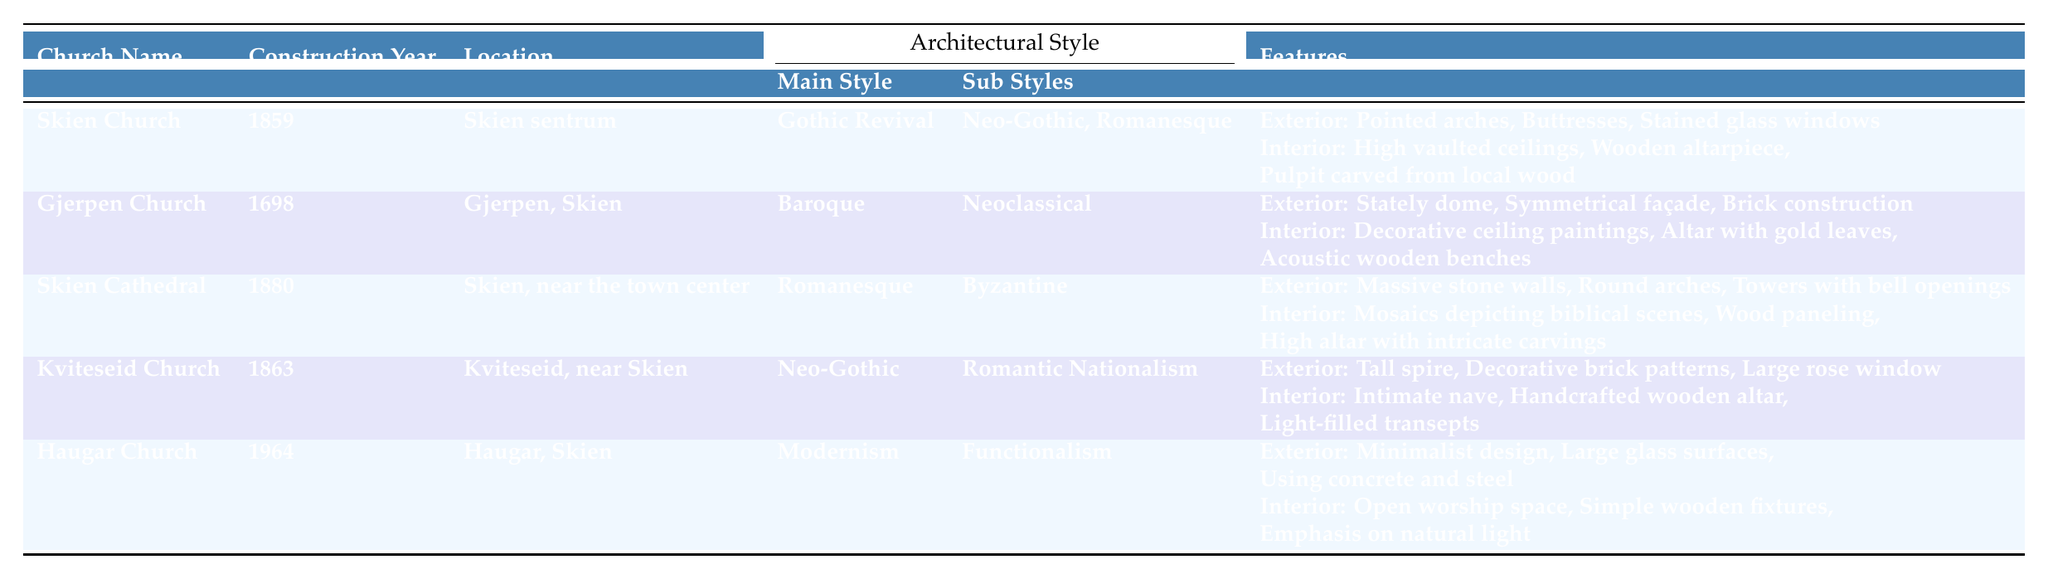What is the architectural style of Skien Church? The table shows that the main architectural style of Skien Church is Gothic Revival.
Answer: Gothic Revival Which church was constructed in 1964? According to the table, the church constructed in 1964 is Haugar Church.
Answer: Haugar Church What features are found in the interior of Gjerpen Church? The table lists the interior features of Gjerpen Church as decorative ceiling paintings, an altar with gold leaves, and acoustic wooden benches.
Answer: Decorative ceiling paintings, altar with gold leaves, acoustic wooden benches Which church has a tall spire as an exterior feature? The table indicates that Kviteseid Church has a tall spire listed as one of its exterior features.
Answer: Kviteseid Church What is the main style of architecture used in Skien Cathedral? The table specifies that the main architectural style of Skien Cathedral is Romanesque.
Answer: Romanesque How many churches exhibit Gothic styles in the table? The table shows that both Skien Church and Kviteseid Church exhibit Gothic styles (Gothic Revival and Neo-Gothic), making a total of two churches.
Answer: 2 Is Gjerpen Church more modern than Haugar Church? Gjerpen Church was constructed in 1698, while Haugar Church was constructed in 1964; therefore, Gjerpen Church is not more modern than Haugar Church.
Answer: No List the construction years of the churches in chronological order. The construction years as listed in the table are 1698 (Gjerpen Church), 1859 (Skien Church), 1863 (Kviteseid Church), 1880 (Skien Cathedral), and 1964 (Haugar Church). Ordered chronologically: 1698, 1859, 1863, 1880, 1964.
Answer: 1698, 1859, 1863, 1880, 1964 What unique feature does Haugar Church have compared to the others? The table indicates that Haugar Church features a minimalist design with large glass surfaces and a focus on natural light, which distinguishes it from the other churches listed.
Answer: Minimalist design, large glass surfaces, emphasis on natural light Which church has the greatest number of exterior features listed? The table shows that Skien Church has three exterior features (pointed arches, buttresses, stained glass windows), while Gjerpen Church, Skien Cathedral, Kviteseid Church, and Haugar Church also have three. Since they all have the same number, there's a tie between them.
Answer: Tie among multiple churches 